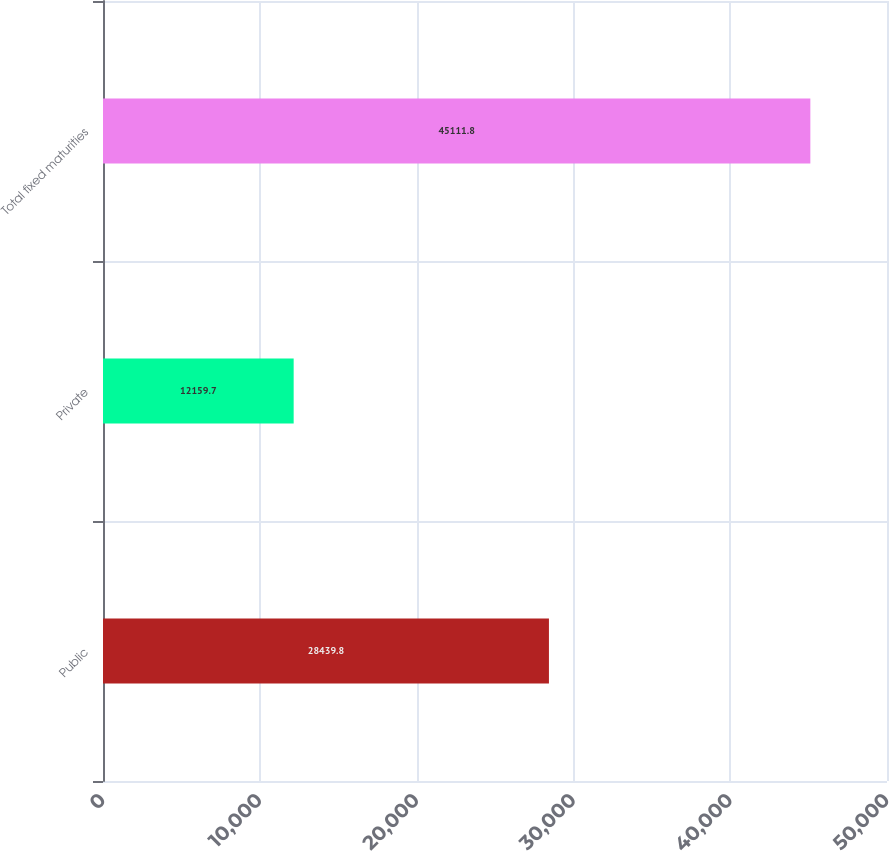Convert chart. <chart><loc_0><loc_0><loc_500><loc_500><bar_chart><fcel>Public<fcel>Private<fcel>Total fixed maturities<nl><fcel>28439.8<fcel>12159.7<fcel>45111.8<nl></chart> 